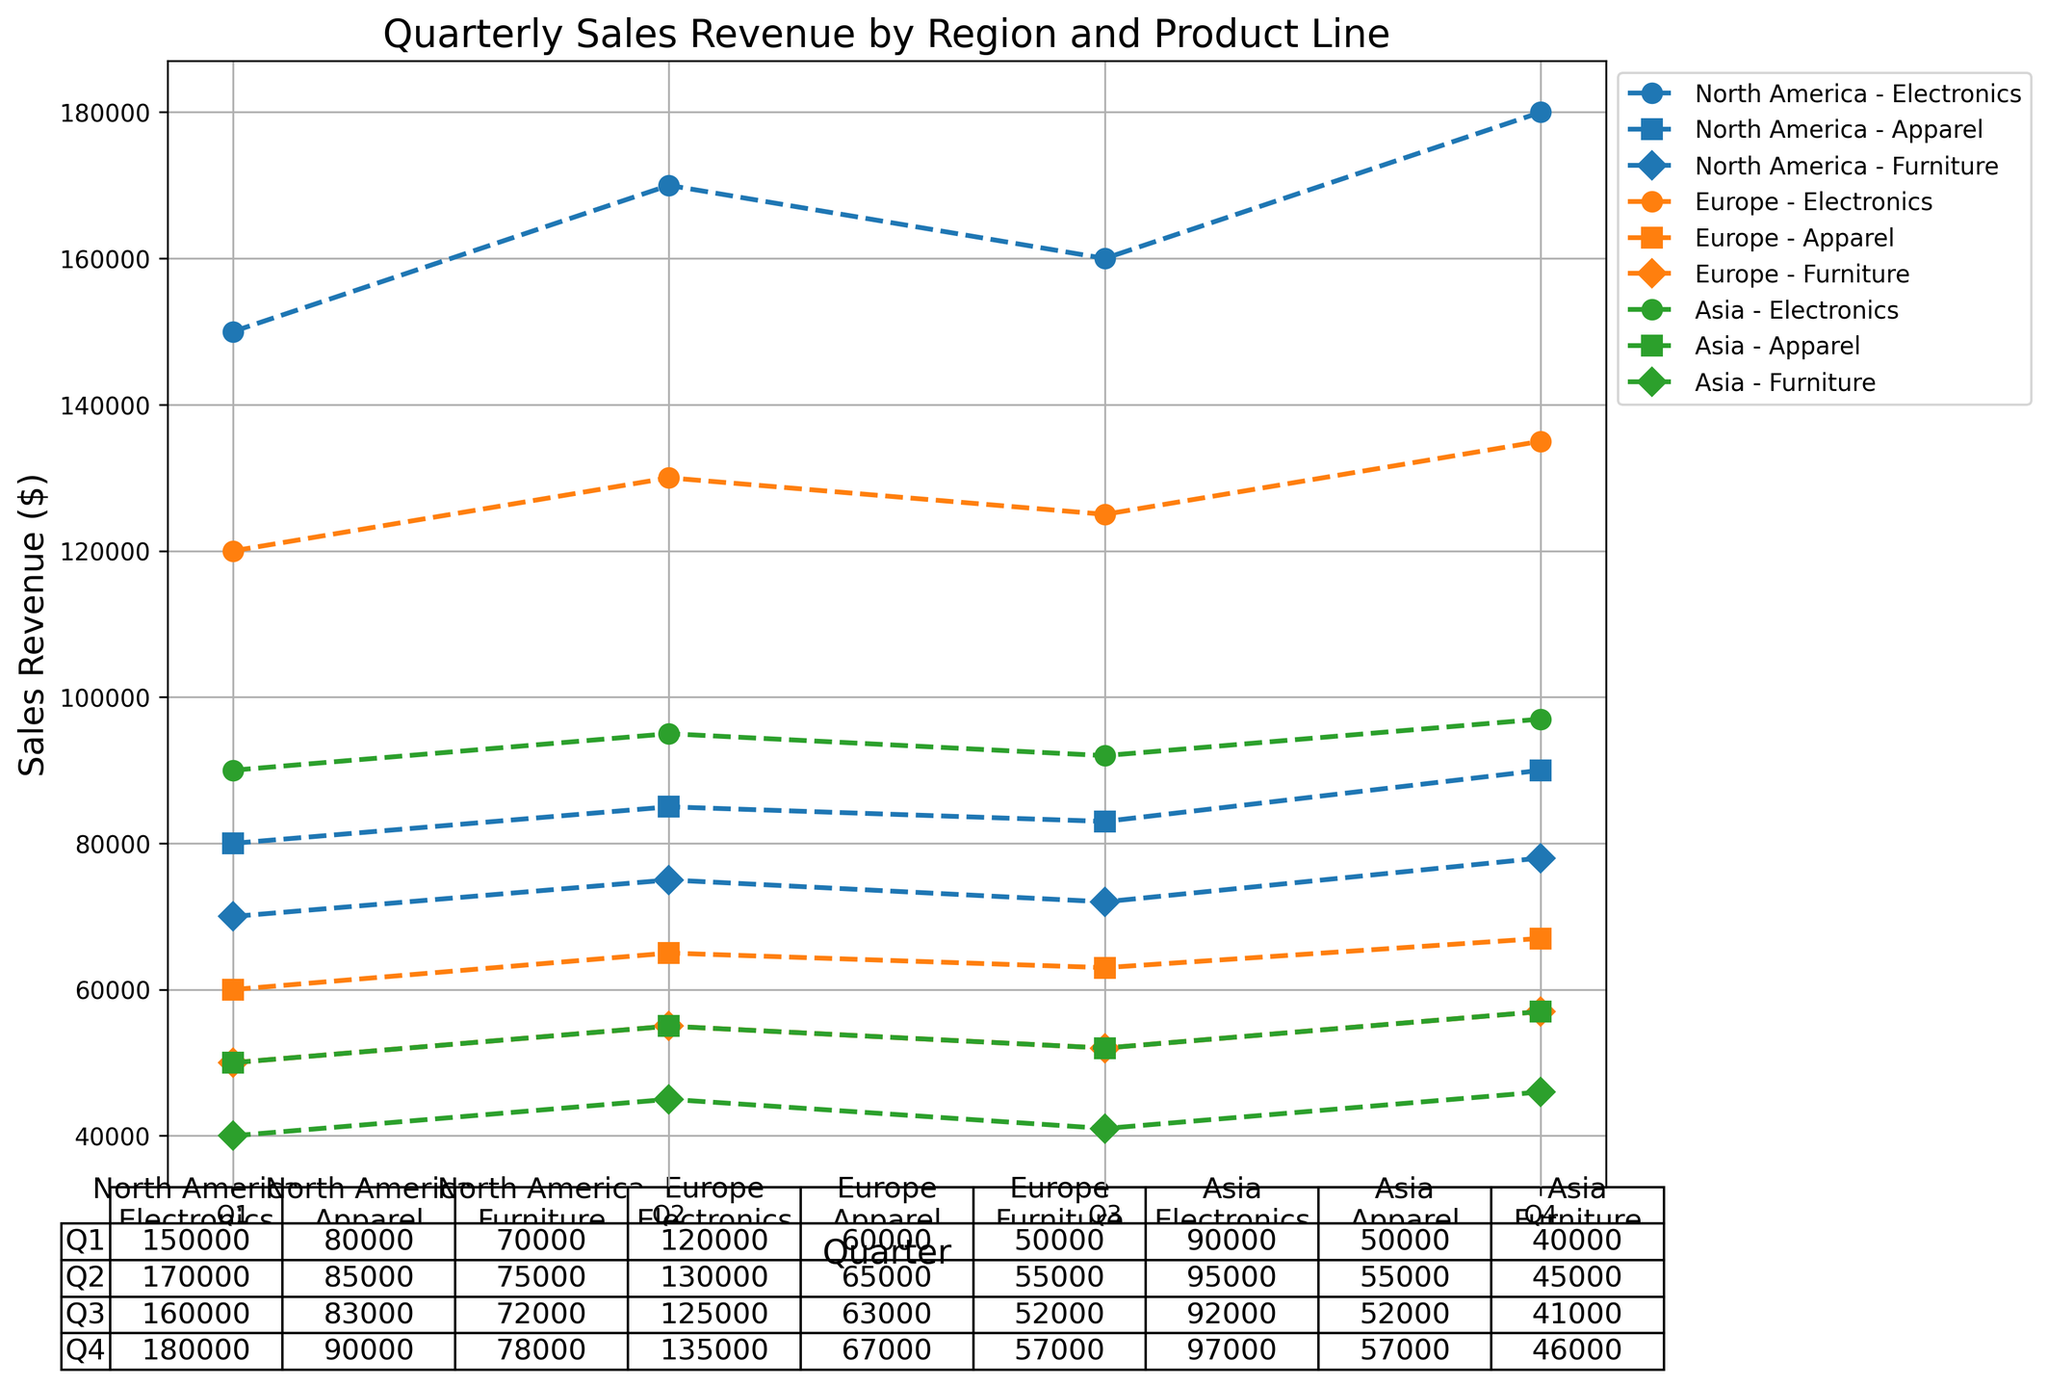What is the total sales revenue for Electronics in Q3 across all regions? To find the total sales revenue for Electronics in Q3, sum the sales from North America, Europe, and Asia for Q3. The values are 160,000 (North America) + 125,000 (Europe) + 92,000 (Asia) = 377,000.
Answer: 377,000 Which region had the highest sales revenue for Apparel in Q4? Compare the sales revenue for Apparel in Q4 across North America, Europe, and Asia. The values are 90,000 (North America), 67,000 (Europe), and 57,000 (Asia). North America has the highest sales revenue.
Answer: North America What is the difference in sales revenue between Electronics and Furniture in Q2 for Europe? Find the sales revenue for Electronics (130,000) and Furniture (55,000) in Q2 for Europe, then calculate the difference: 130,000 - 55,000 = 75,000.
Answer: 75,000 What is the average sales revenue of Furniture across all quarters in Asia? Calculate the sum of Furniture sales revenue for all quarters in Asia: 40,000 (Q1) + 45,000 (Q2) + 41,000 (Q3) + 46,000 (Q4) = 172,000. Then, divide by the number of quarters (4): 172,000 / 4 = 43,000.
Answer: 43,000 Which product line had the highest total sales revenue in North America across all quarters? Sum the sales revenue for each product line in North America across all quarters: Electronics (150,000 + 170,000 + 160,000 + 180,000 = 660,000), Apparel (80,000 + 85,000 + 83,000 + 90,000 = 338,000), Furniture (70,000 + 75,000 + 72,000 + 78,000 = 295,000). Electronics had the highest total sales revenue.
Answer: Electronics How did the sales revenue of Electronics in Asia change from Q1 to Q4? Observe the sales revenue for Electronics in Asia from Q1 (90,000) to Q4 (97,000). The change is 97,000 - 90,000 = 7,000.
Answer: Increased by 7,000 What is the sum of Apparel and Furniture sales revenue in Europe for Q1? Add the sales revenue for Apparel and Furniture in Europe for Q1: 60,000 (Apparel) + 50,000 (Furniture) = 110,000.
Answer: 110,000 In which quarter did Europe have its highest total sales revenue for all product lines combined? Summing up the sales revenue of all product lines for each quarter in Europe: Q1 (120,000 + 60,000 + 50,000 = 230,000), Q2 (130,000 + 65,000 + 55,000 = 250,000), Q3 (125,000 + 63,000 + 52,000 = 240,000), Q4 (135,000 + 67,000 + 57,000 = 259,000). Europe had the highest total sales revenue in Q4.
Answer: Q4 